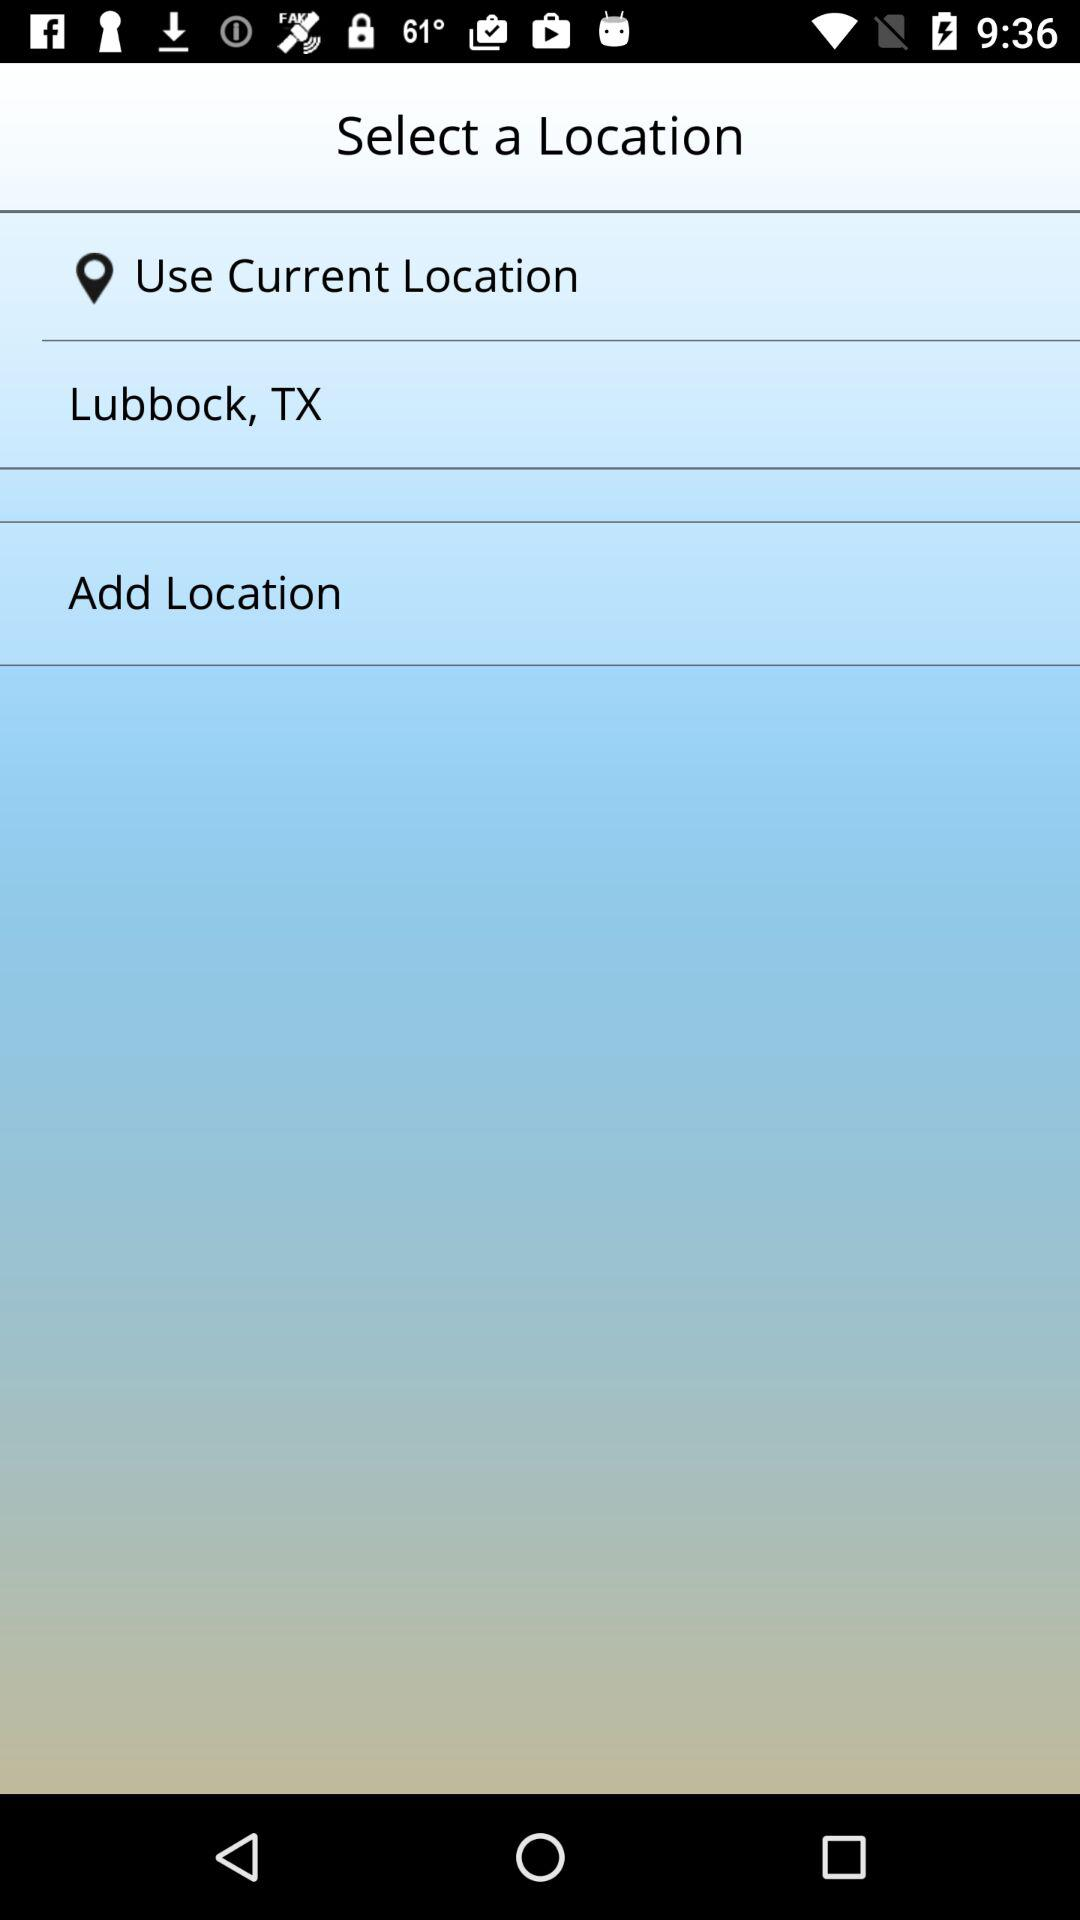What is the selected current location? The selected current location is Lubbock, TX. 